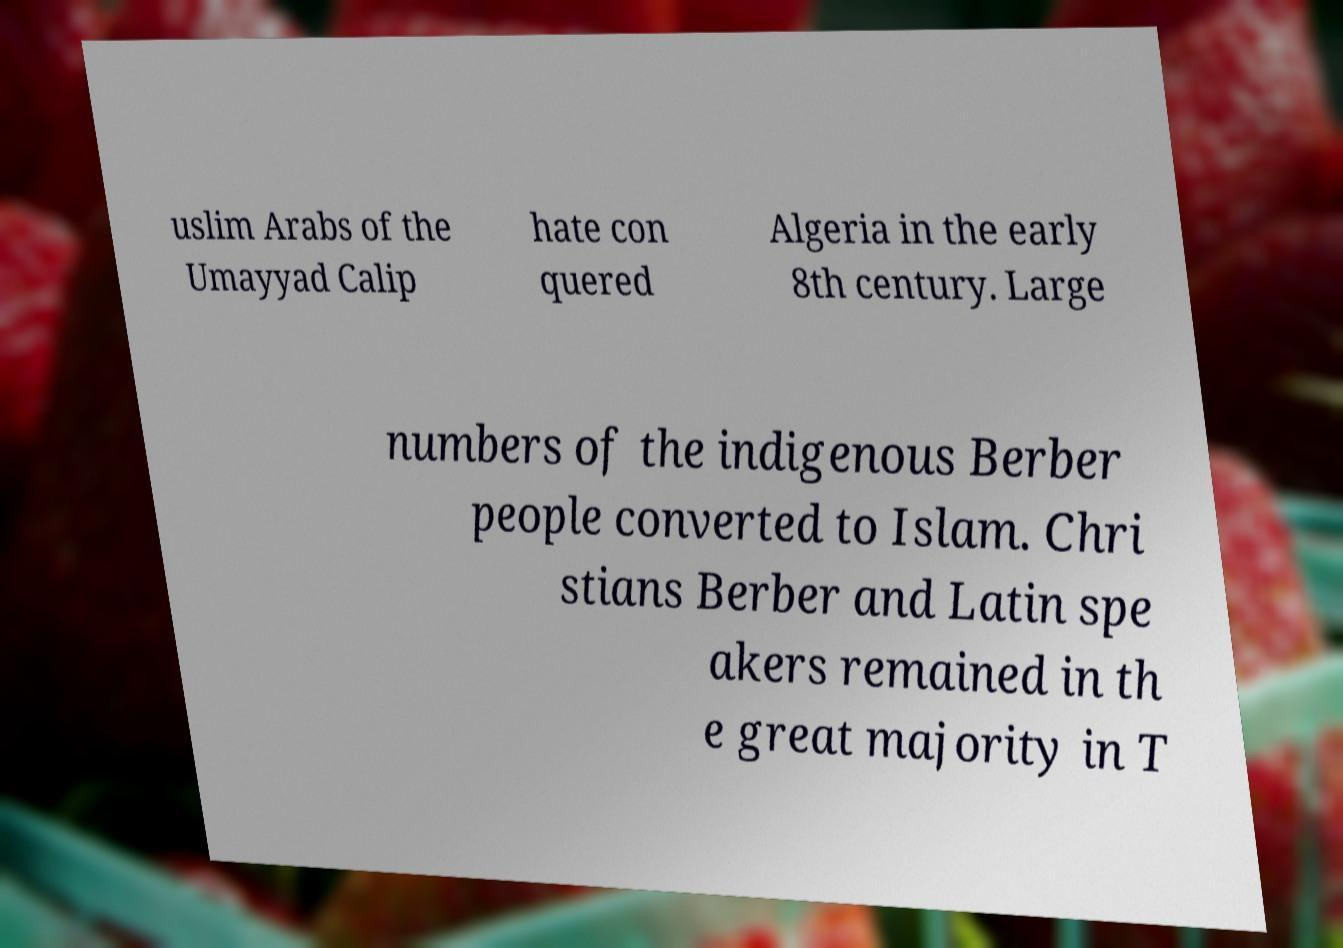What messages or text are displayed in this image? I need them in a readable, typed format. uslim Arabs of the Umayyad Calip hate con quered Algeria in the early 8th century. Large numbers of the indigenous Berber people converted to Islam. Chri stians Berber and Latin spe akers remained in th e great majority in T 